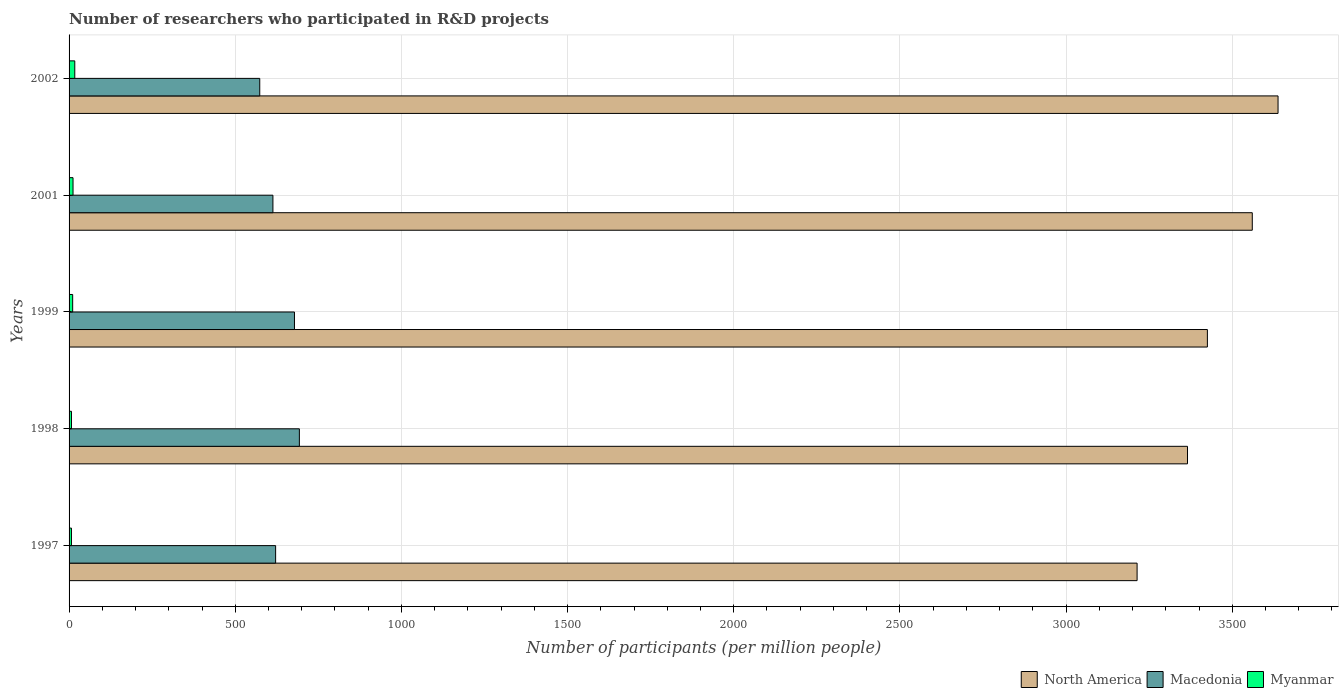Are the number of bars on each tick of the Y-axis equal?
Offer a terse response. Yes. What is the label of the 2nd group of bars from the top?
Give a very brief answer. 2001. In how many cases, is the number of bars for a given year not equal to the number of legend labels?
Provide a short and direct response. 0. What is the number of researchers who participated in R&D projects in North America in 2002?
Give a very brief answer. 3637.78. Across all years, what is the maximum number of researchers who participated in R&D projects in North America?
Your answer should be very brief. 3637.78. Across all years, what is the minimum number of researchers who participated in R&D projects in North America?
Ensure brevity in your answer.  3213.68. In which year was the number of researchers who participated in R&D projects in Myanmar minimum?
Offer a very short reply. 1997. What is the total number of researchers who participated in R&D projects in Myanmar in the graph?
Your response must be concise. 54.32. What is the difference between the number of researchers who participated in R&D projects in Macedonia in 1998 and that in 2002?
Give a very brief answer. 119.2. What is the difference between the number of researchers who participated in R&D projects in North America in 1997 and the number of researchers who participated in R&D projects in Myanmar in 1998?
Your answer should be very brief. 3206.46. What is the average number of researchers who participated in R&D projects in Myanmar per year?
Offer a terse response. 10.86. In the year 1998, what is the difference between the number of researchers who participated in R&D projects in North America and number of researchers who participated in R&D projects in Macedonia?
Provide a short and direct response. 2672.37. In how many years, is the number of researchers who participated in R&D projects in Myanmar greater than 3500 ?
Keep it short and to the point. 0. What is the ratio of the number of researchers who participated in R&D projects in Myanmar in 1997 to that in 1999?
Make the answer very short. 0.66. Is the number of researchers who participated in R&D projects in Macedonia in 1999 less than that in 2002?
Your answer should be compact. No. What is the difference between the highest and the second highest number of researchers who participated in R&D projects in Macedonia?
Your answer should be compact. 14.74. What is the difference between the highest and the lowest number of researchers who participated in R&D projects in North America?
Make the answer very short. 424.09. What does the 2nd bar from the top in 1998 represents?
Offer a very short reply. Macedonia. What does the 3rd bar from the bottom in 2001 represents?
Your response must be concise. Myanmar. Is it the case that in every year, the sum of the number of researchers who participated in R&D projects in Myanmar and number of researchers who participated in R&D projects in Macedonia is greater than the number of researchers who participated in R&D projects in North America?
Offer a terse response. No. Are all the bars in the graph horizontal?
Your response must be concise. Yes. How many years are there in the graph?
Make the answer very short. 5. Are the values on the major ticks of X-axis written in scientific E-notation?
Offer a terse response. No. Does the graph contain any zero values?
Make the answer very short. No. Where does the legend appear in the graph?
Give a very brief answer. Bottom right. How are the legend labels stacked?
Keep it short and to the point. Horizontal. What is the title of the graph?
Keep it short and to the point. Number of researchers who participated in R&D projects. Does "Jamaica" appear as one of the legend labels in the graph?
Provide a short and direct response. No. What is the label or title of the X-axis?
Your answer should be compact. Number of participants (per million people). What is the label or title of the Y-axis?
Give a very brief answer. Years. What is the Number of participants (per million people) in North America in 1997?
Give a very brief answer. 3213.68. What is the Number of participants (per million people) of Macedonia in 1997?
Your response must be concise. 621.53. What is the Number of participants (per million people) of Myanmar in 1997?
Your response must be concise. 7.17. What is the Number of participants (per million people) in North America in 1998?
Offer a terse response. 3365.33. What is the Number of participants (per million people) of Macedonia in 1998?
Your response must be concise. 692.96. What is the Number of participants (per million people) of Myanmar in 1998?
Your response must be concise. 7.22. What is the Number of participants (per million people) of North America in 1999?
Ensure brevity in your answer.  3425.18. What is the Number of participants (per million people) of Macedonia in 1999?
Ensure brevity in your answer.  678.22. What is the Number of participants (per million people) of Myanmar in 1999?
Ensure brevity in your answer.  10.83. What is the Number of participants (per million people) in North America in 2001?
Ensure brevity in your answer.  3560.24. What is the Number of participants (per million people) in Macedonia in 2001?
Provide a short and direct response. 613.38. What is the Number of participants (per million people) in Myanmar in 2001?
Offer a very short reply. 11.91. What is the Number of participants (per million people) in North America in 2002?
Make the answer very short. 3637.78. What is the Number of participants (per million people) in Macedonia in 2002?
Provide a succinct answer. 573.76. What is the Number of participants (per million people) in Myanmar in 2002?
Provide a short and direct response. 17.19. Across all years, what is the maximum Number of participants (per million people) in North America?
Offer a very short reply. 3637.78. Across all years, what is the maximum Number of participants (per million people) of Macedonia?
Your answer should be very brief. 692.96. Across all years, what is the maximum Number of participants (per million people) in Myanmar?
Make the answer very short. 17.19. Across all years, what is the minimum Number of participants (per million people) in North America?
Offer a terse response. 3213.68. Across all years, what is the minimum Number of participants (per million people) in Macedonia?
Offer a very short reply. 573.76. Across all years, what is the minimum Number of participants (per million people) of Myanmar?
Make the answer very short. 7.17. What is the total Number of participants (per million people) in North America in the graph?
Provide a succinct answer. 1.72e+04. What is the total Number of participants (per million people) of Macedonia in the graph?
Provide a short and direct response. 3179.85. What is the total Number of participants (per million people) of Myanmar in the graph?
Your answer should be compact. 54.32. What is the difference between the Number of participants (per million people) of North America in 1997 and that in 1998?
Offer a very short reply. -151.65. What is the difference between the Number of participants (per million people) in Macedonia in 1997 and that in 1998?
Give a very brief answer. -71.43. What is the difference between the Number of participants (per million people) in Myanmar in 1997 and that in 1998?
Offer a very short reply. -0.06. What is the difference between the Number of participants (per million people) in North America in 1997 and that in 1999?
Give a very brief answer. -211.49. What is the difference between the Number of participants (per million people) in Macedonia in 1997 and that in 1999?
Give a very brief answer. -56.69. What is the difference between the Number of participants (per million people) of Myanmar in 1997 and that in 1999?
Your answer should be compact. -3.66. What is the difference between the Number of participants (per million people) in North America in 1997 and that in 2001?
Ensure brevity in your answer.  -346.56. What is the difference between the Number of participants (per million people) of Macedonia in 1997 and that in 2001?
Offer a very short reply. 8.15. What is the difference between the Number of participants (per million people) in Myanmar in 1997 and that in 2001?
Ensure brevity in your answer.  -4.74. What is the difference between the Number of participants (per million people) of North America in 1997 and that in 2002?
Your response must be concise. -424.09. What is the difference between the Number of participants (per million people) of Macedonia in 1997 and that in 2002?
Your answer should be very brief. 47.76. What is the difference between the Number of participants (per million people) of Myanmar in 1997 and that in 2002?
Keep it short and to the point. -10.02. What is the difference between the Number of participants (per million people) of North America in 1998 and that in 1999?
Provide a succinct answer. -59.84. What is the difference between the Number of participants (per million people) in Macedonia in 1998 and that in 1999?
Your answer should be very brief. 14.74. What is the difference between the Number of participants (per million people) of Myanmar in 1998 and that in 1999?
Your response must be concise. -3.6. What is the difference between the Number of participants (per million people) of North America in 1998 and that in 2001?
Give a very brief answer. -194.91. What is the difference between the Number of participants (per million people) in Macedonia in 1998 and that in 2001?
Provide a short and direct response. 79.58. What is the difference between the Number of participants (per million people) of Myanmar in 1998 and that in 2001?
Provide a succinct answer. -4.69. What is the difference between the Number of participants (per million people) in North America in 1998 and that in 2002?
Provide a succinct answer. -272.45. What is the difference between the Number of participants (per million people) in Macedonia in 1998 and that in 2002?
Give a very brief answer. 119.2. What is the difference between the Number of participants (per million people) in Myanmar in 1998 and that in 2002?
Your response must be concise. -9.97. What is the difference between the Number of participants (per million people) of North America in 1999 and that in 2001?
Your response must be concise. -135.07. What is the difference between the Number of participants (per million people) in Macedonia in 1999 and that in 2001?
Ensure brevity in your answer.  64.84. What is the difference between the Number of participants (per million people) of Myanmar in 1999 and that in 2001?
Offer a terse response. -1.08. What is the difference between the Number of participants (per million people) in North America in 1999 and that in 2002?
Your answer should be compact. -212.6. What is the difference between the Number of participants (per million people) of Macedonia in 1999 and that in 2002?
Offer a terse response. 104.45. What is the difference between the Number of participants (per million people) in Myanmar in 1999 and that in 2002?
Keep it short and to the point. -6.36. What is the difference between the Number of participants (per million people) of North America in 2001 and that in 2002?
Provide a succinct answer. -77.53. What is the difference between the Number of participants (per million people) in Macedonia in 2001 and that in 2002?
Your answer should be very brief. 39.62. What is the difference between the Number of participants (per million people) in Myanmar in 2001 and that in 2002?
Offer a terse response. -5.28. What is the difference between the Number of participants (per million people) of North America in 1997 and the Number of participants (per million people) of Macedonia in 1998?
Give a very brief answer. 2520.72. What is the difference between the Number of participants (per million people) in North America in 1997 and the Number of participants (per million people) in Myanmar in 1998?
Your answer should be compact. 3206.46. What is the difference between the Number of participants (per million people) of Macedonia in 1997 and the Number of participants (per million people) of Myanmar in 1998?
Your response must be concise. 614.3. What is the difference between the Number of participants (per million people) in North America in 1997 and the Number of participants (per million people) in Macedonia in 1999?
Offer a terse response. 2535.47. What is the difference between the Number of participants (per million people) of North America in 1997 and the Number of participants (per million people) of Myanmar in 1999?
Keep it short and to the point. 3202.86. What is the difference between the Number of participants (per million people) in Macedonia in 1997 and the Number of participants (per million people) in Myanmar in 1999?
Your answer should be compact. 610.7. What is the difference between the Number of participants (per million people) in North America in 1997 and the Number of participants (per million people) in Macedonia in 2001?
Keep it short and to the point. 2600.3. What is the difference between the Number of participants (per million people) in North America in 1997 and the Number of participants (per million people) in Myanmar in 2001?
Keep it short and to the point. 3201.77. What is the difference between the Number of participants (per million people) in Macedonia in 1997 and the Number of participants (per million people) in Myanmar in 2001?
Keep it short and to the point. 609.62. What is the difference between the Number of participants (per million people) in North America in 1997 and the Number of participants (per million people) in Macedonia in 2002?
Make the answer very short. 2639.92. What is the difference between the Number of participants (per million people) in North America in 1997 and the Number of participants (per million people) in Myanmar in 2002?
Offer a very short reply. 3196.49. What is the difference between the Number of participants (per million people) of Macedonia in 1997 and the Number of participants (per million people) of Myanmar in 2002?
Ensure brevity in your answer.  604.34. What is the difference between the Number of participants (per million people) of North America in 1998 and the Number of participants (per million people) of Macedonia in 1999?
Offer a terse response. 2687.11. What is the difference between the Number of participants (per million people) in North America in 1998 and the Number of participants (per million people) in Myanmar in 1999?
Your response must be concise. 3354.5. What is the difference between the Number of participants (per million people) of Macedonia in 1998 and the Number of participants (per million people) of Myanmar in 1999?
Provide a succinct answer. 682.13. What is the difference between the Number of participants (per million people) of North America in 1998 and the Number of participants (per million people) of Macedonia in 2001?
Make the answer very short. 2751.95. What is the difference between the Number of participants (per million people) in North America in 1998 and the Number of participants (per million people) in Myanmar in 2001?
Ensure brevity in your answer.  3353.42. What is the difference between the Number of participants (per million people) of Macedonia in 1998 and the Number of participants (per million people) of Myanmar in 2001?
Provide a short and direct response. 681.05. What is the difference between the Number of participants (per million people) in North America in 1998 and the Number of participants (per million people) in Macedonia in 2002?
Provide a short and direct response. 2791.57. What is the difference between the Number of participants (per million people) of North America in 1998 and the Number of participants (per million people) of Myanmar in 2002?
Ensure brevity in your answer.  3348.14. What is the difference between the Number of participants (per million people) of Macedonia in 1998 and the Number of participants (per million people) of Myanmar in 2002?
Keep it short and to the point. 675.77. What is the difference between the Number of participants (per million people) in North America in 1999 and the Number of participants (per million people) in Macedonia in 2001?
Give a very brief answer. 2811.8. What is the difference between the Number of participants (per million people) in North America in 1999 and the Number of participants (per million people) in Myanmar in 2001?
Provide a short and direct response. 3413.27. What is the difference between the Number of participants (per million people) of Macedonia in 1999 and the Number of participants (per million people) of Myanmar in 2001?
Offer a terse response. 666.31. What is the difference between the Number of participants (per million people) in North America in 1999 and the Number of participants (per million people) in Macedonia in 2002?
Give a very brief answer. 2851.41. What is the difference between the Number of participants (per million people) in North America in 1999 and the Number of participants (per million people) in Myanmar in 2002?
Keep it short and to the point. 3407.99. What is the difference between the Number of participants (per million people) of Macedonia in 1999 and the Number of participants (per million people) of Myanmar in 2002?
Provide a short and direct response. 661.03. What is the difference between the Number of participants (per million people) in North America in 2001 and the Number of participants (per million people) in Macedonia in 2002?
Offer a terse response. 2986.48. What is the difference between the Number of participants (per million people) of North America in 2001 and the Number of participants (per million people) of Myanmar in 2002?
Offer a terse response. 3543.05. What is the difference between the Number of participants (per million people) of Macedonia in 2001 and the Number of participants (per million people) of Myanmar in 2002?
Give a very brief answer. 596.19. What is the average Number of participants (per million people) of North America per year?
Give a very brief answer. 3440.44. What is the average Number of participants (per million people) in Macedonia per year?
Give a very brief answer. 635.97. What is the average Number of participants (per million people) of Myanmar per year?
Provide a succinct answer. 10.86. In the year 1997, what is the difference between the Number of participants (per million people) of North America and Number of participants (per million people) of Macedonia?
Offer a terse response. 2592.16. In the year 1997, what is the difference between the Number of participants (per million people) in North America and Number of participants (per million people) in Myanmar?
Give a very brief answer. 3206.52. In the year 1997, what is the difference between the Number of participants (per million people) in Macedonia and Number of participants (per million people) in Myanmar?
Provide a short and direct response. 614.36. In the year 1998, what is the difference between the Number of participants (per million people) in North America and Number of participants (per million people) in Macedonia?
Your answer should be compact. 2672.37. In the year 1998, what is the difference between the Number of participants (per million people) in North America and Number of participants (per million people) in Myanmar?
Offer a very short reply. 3358.11. In the year 1998, what is the difference between the Number of participants (per million people) in Macedonia and Number of participants (per million people) in Myanmar?
Provide a short and direct response. 685.74. In the year 1999, what is the difference between the Number of participants (per million people) of North America and Number of participants (per million people) of Macedonia?
Your answer should be compact. 2746.96. In the year 1999, what is the difference between the Number of participants (per million people) of North America and Number of participants (per million people) of Myanmar?
Offer a very short reply. 3414.35. In the year 1999, what is the difference between the Number of participants (per million people) in Macedonia and Number of participants (per million people) in Myanmar?
Your answer should be compact. 667.39. In the year 2001, what is the difference between the Number of participants (per million people) of North America and Number of participants (per million people) of Macedonia?
Provide a short and direct response. 2946.86. In the year 2001, what is the difference between the Number of participants (per million people) of North America and Number of participants (per million people) of Myanmar?
Your answer should be compact. 3548.33. In the year 2001, what is the difference between the Number of participants (per million people) in Macedonia and Number of participants (per million people) in Myanmar?
Your answer should be compact. 601.47. In the year 2002, what is the difference between the Number of participants (per million people) in North America and Number of participants (per million people) in Macedonia?
Your response must be concise. 3064.01. In the year 2002, what is the difference between the Number of participants (per million people) in North America and Number of participants (per million people) in Myanmar?
Keep it short and to the point. 3620.59. In the year 2002, what is the difference between the Number of participants (per million people) in Macedonia and Number of participants (per million people) in Myanmar?
Ensure brevity in your answer.  556.57. What is the ratio of the Number of participants (per million people) in North America in 1997 to that in 1998?
Offer a very short reply. 0.95. What is the ratio of the Number of participants (per million people) of Macedonia in 1997 to that in 1998?
Give a very brief answer. 0.9. What is the ratio of the Number of participants (per million people) in Myanmar in 1997 to that in 1998?
Offer a terse response. 0.99. What is the ratio of the Number of participants (per million people) of North America in 1997 to that in 1999?
Ensure brevity in your answer.  0.94. What is the ratio of the Number of participants (per million people) of Macedonia in 1997 to that in 1999?
Offer a terse response. 0.92. What is the ratio of the Number of participants (per million people) of Myanmar in 1997 to that in 1999?
Offer a terse response. 0.66. What is the ratio of the Number of participants (per million people) in North America in 1997 to that in 2001?
Ensure brevity in your answer.  0.9. What is the ratio of the Number of participants (per million people) of Macedonia in 1997 to that in 2001?
Your response must be concise. 1.01. What is the ratio of the Number of participants (per million people) of Myanmar in 1997 to that in 2001?
Offer a terse response. 0.6. What is the ratio of the Number of participants (per million people) of North America in 1997 to that in 2002?
Make the answer very short. 0.88. What is the ratio of the Number of participants (per million people) of Macedonia in 1997 to that in 2002?
Ensure brevity in your answer.  1.08. What is the ratio of the Number of participants (per million people) in Myanmar in 1997 to that in 2002?
Your response must be concise. 0.42. What is the ratio of the Number of participants (per million people) in North America in 1998 to that in 1999?
Your response must be concise. 0.98. What is the ratio of the Number of participants (per million people) of Macedonia in 1998 to that in 1999?
Keep it short and to the point. 1.02. What is the ratio of the Number of participants (per million people) in Myanmar in 1998 to that in 1999?
Keep it short and to the point. 0.67. What is the ratio of the Number of participants (per million people) in North America in 1998 to that in 2001?
Ensure brevity in your answer.  0.95. What is the ratio of the Number of participants (per million people) of Macedonia in 1998 to that in 2001?
Provide a succinct answer. 1.13. What is the ratio of the Number of participants (per million people) in Myanmar in 1998 to that in 2001?
Provide a short and direct response. 0.61. What is the ratio of the Number of participants (per million people) of North America in 1998 to that in 2002?
Your answer should be very brief. 0.93. What is the ratio of the Number of participants (per million people) in Macedonia in 1998 to that in 2002?
Your response must be concise. 1.21. What is the ratio of the Number of participants (per million people) of Myanmar in 1998 to that in 2002?
Offer a very short reply. 0.42. What is the ratio of the Number of participants (per million people) of North America in 1999 to that in 2001?
Your response must be concise. 0.96. What is the ratio of the Number of participants (per million people) of Macedonia in 1999 to that in 2001?
Offer a terse response. 1.11. What is the ratio of the Number of participants (per million people) of Myanmar in 1999 to that in 2001?
Your response must be concise. 0.91. What is the ratio of the Number of participants (per million people) of North America in 1999 to that in 2002?
Offer a terse response. 0.94. What is the ratio of the Number of participants (per million people) in Macedonia in 1999 to that in 2002?
Make the answer very short. 1.18. What is the ratio of the Number of participants (per million people) in Myanmar in 1999 to that in 2002?
Provide a short and direct response. 0.63. What is the ratio of the Number of participants (per million people) in North America in 2001 to that in 2002?
Keep it short and to the point. 0.98. What is the ratio of the Number of participants (per million people) of Macedonia in 2001 to that in 2002?
Your answer should be compact. 1.07. What is the ratio of the Number of participants (per million people) in Myanmar in 2001 to that in 2002?
Your response must be concise. 0.69. What is the difference between the highest and the second highest Number of participants (per million people) in North America?
Provide a succinct answer. 77.53. What is the difference between the highest and the second highest Number of participants (per million people) of Macedonia?
Your answer should be very brief. 14.74. What is the difference between the highest and the second highest Number of participants (per million people) of Myanmar?
Provide a succinct answer. 5.28. What is the difference between the highest and the lowest Number of participants (per million people) in North America?
Give a very brief answer. 424.09. What is the difference between the highest and the lowest Number of participants (per million people) of Macedonia?
Keep it short and to the point. 119.2. What is the difference between the highest and the lowest Number of participants (per million people) of Myanmar?
Keep it short and to the point. 10.02. 